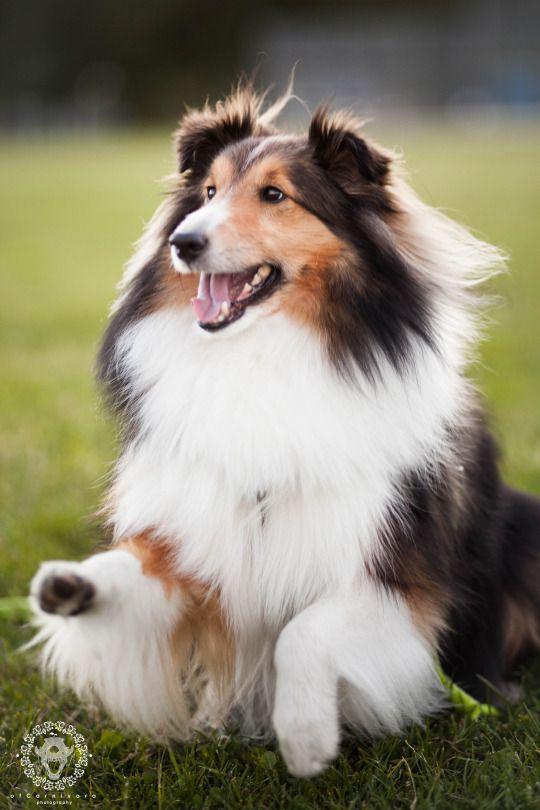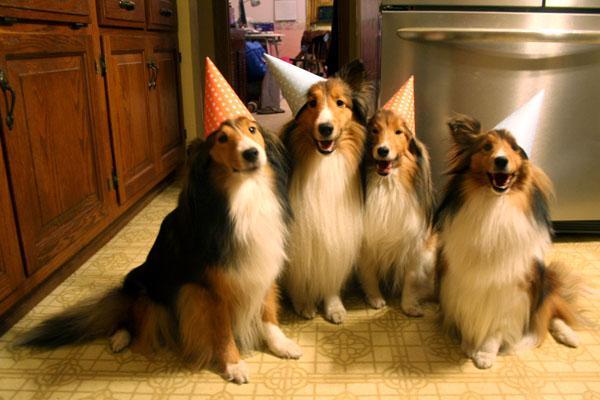The first image is the image on the left, the second image is the image on the right. Considering the images on both sides, is "An image shows a woman in black next to at least one collie dog." valid? Answer yes or no. No. The first image is the image on the left, the second image is the image on the right. For the images shown, is this caption "One dog photo is taken outside in a grassy area, while the other is taken inside in a private home setting." true? Answer yes or no. Yes. 